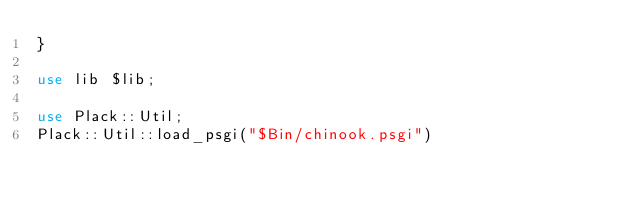Convert code to text. <code><loc_0><loc_0><loc_500><loc_500><_Perl_>}

use lib $lib;

use Plack::Util;
Plack::Util::load_psgi("$Bin/chinook.psgi")
</code> 